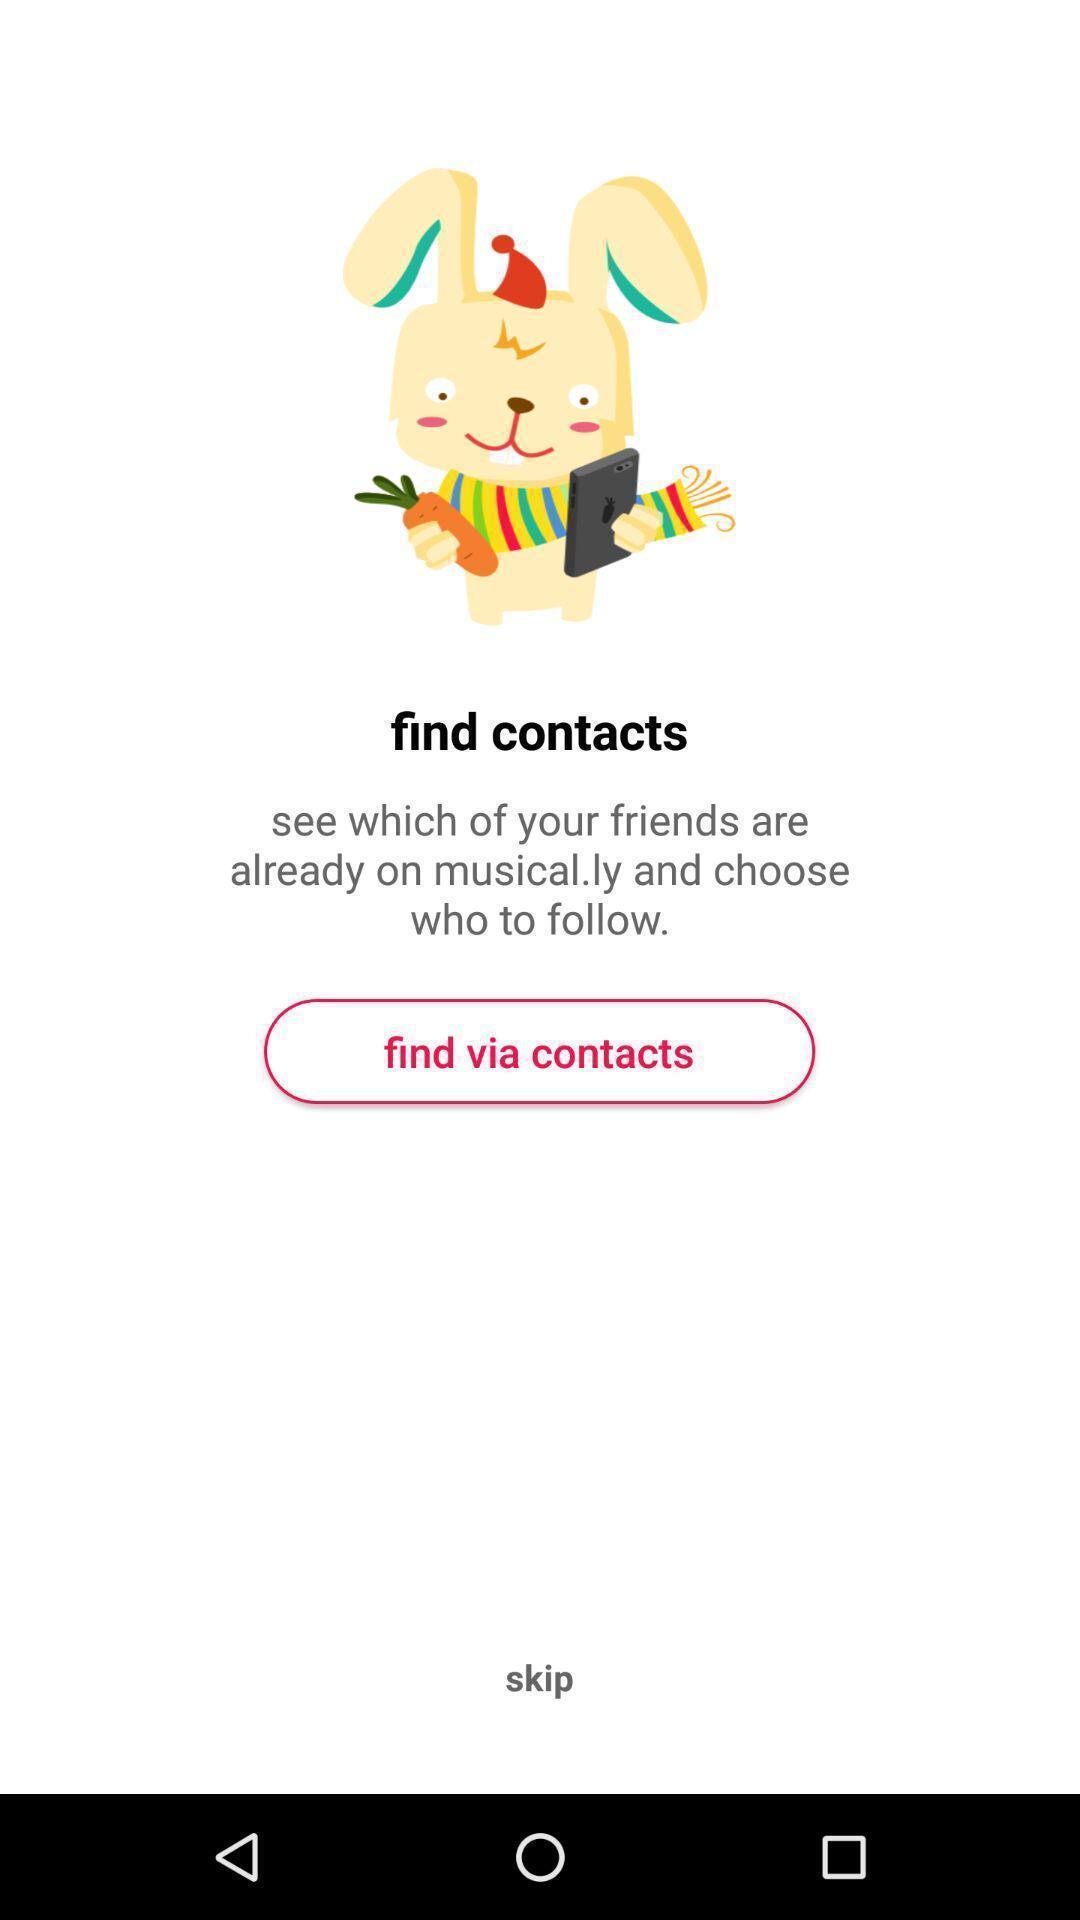What can you discern from this picture? Screen showing find via contacts options. 